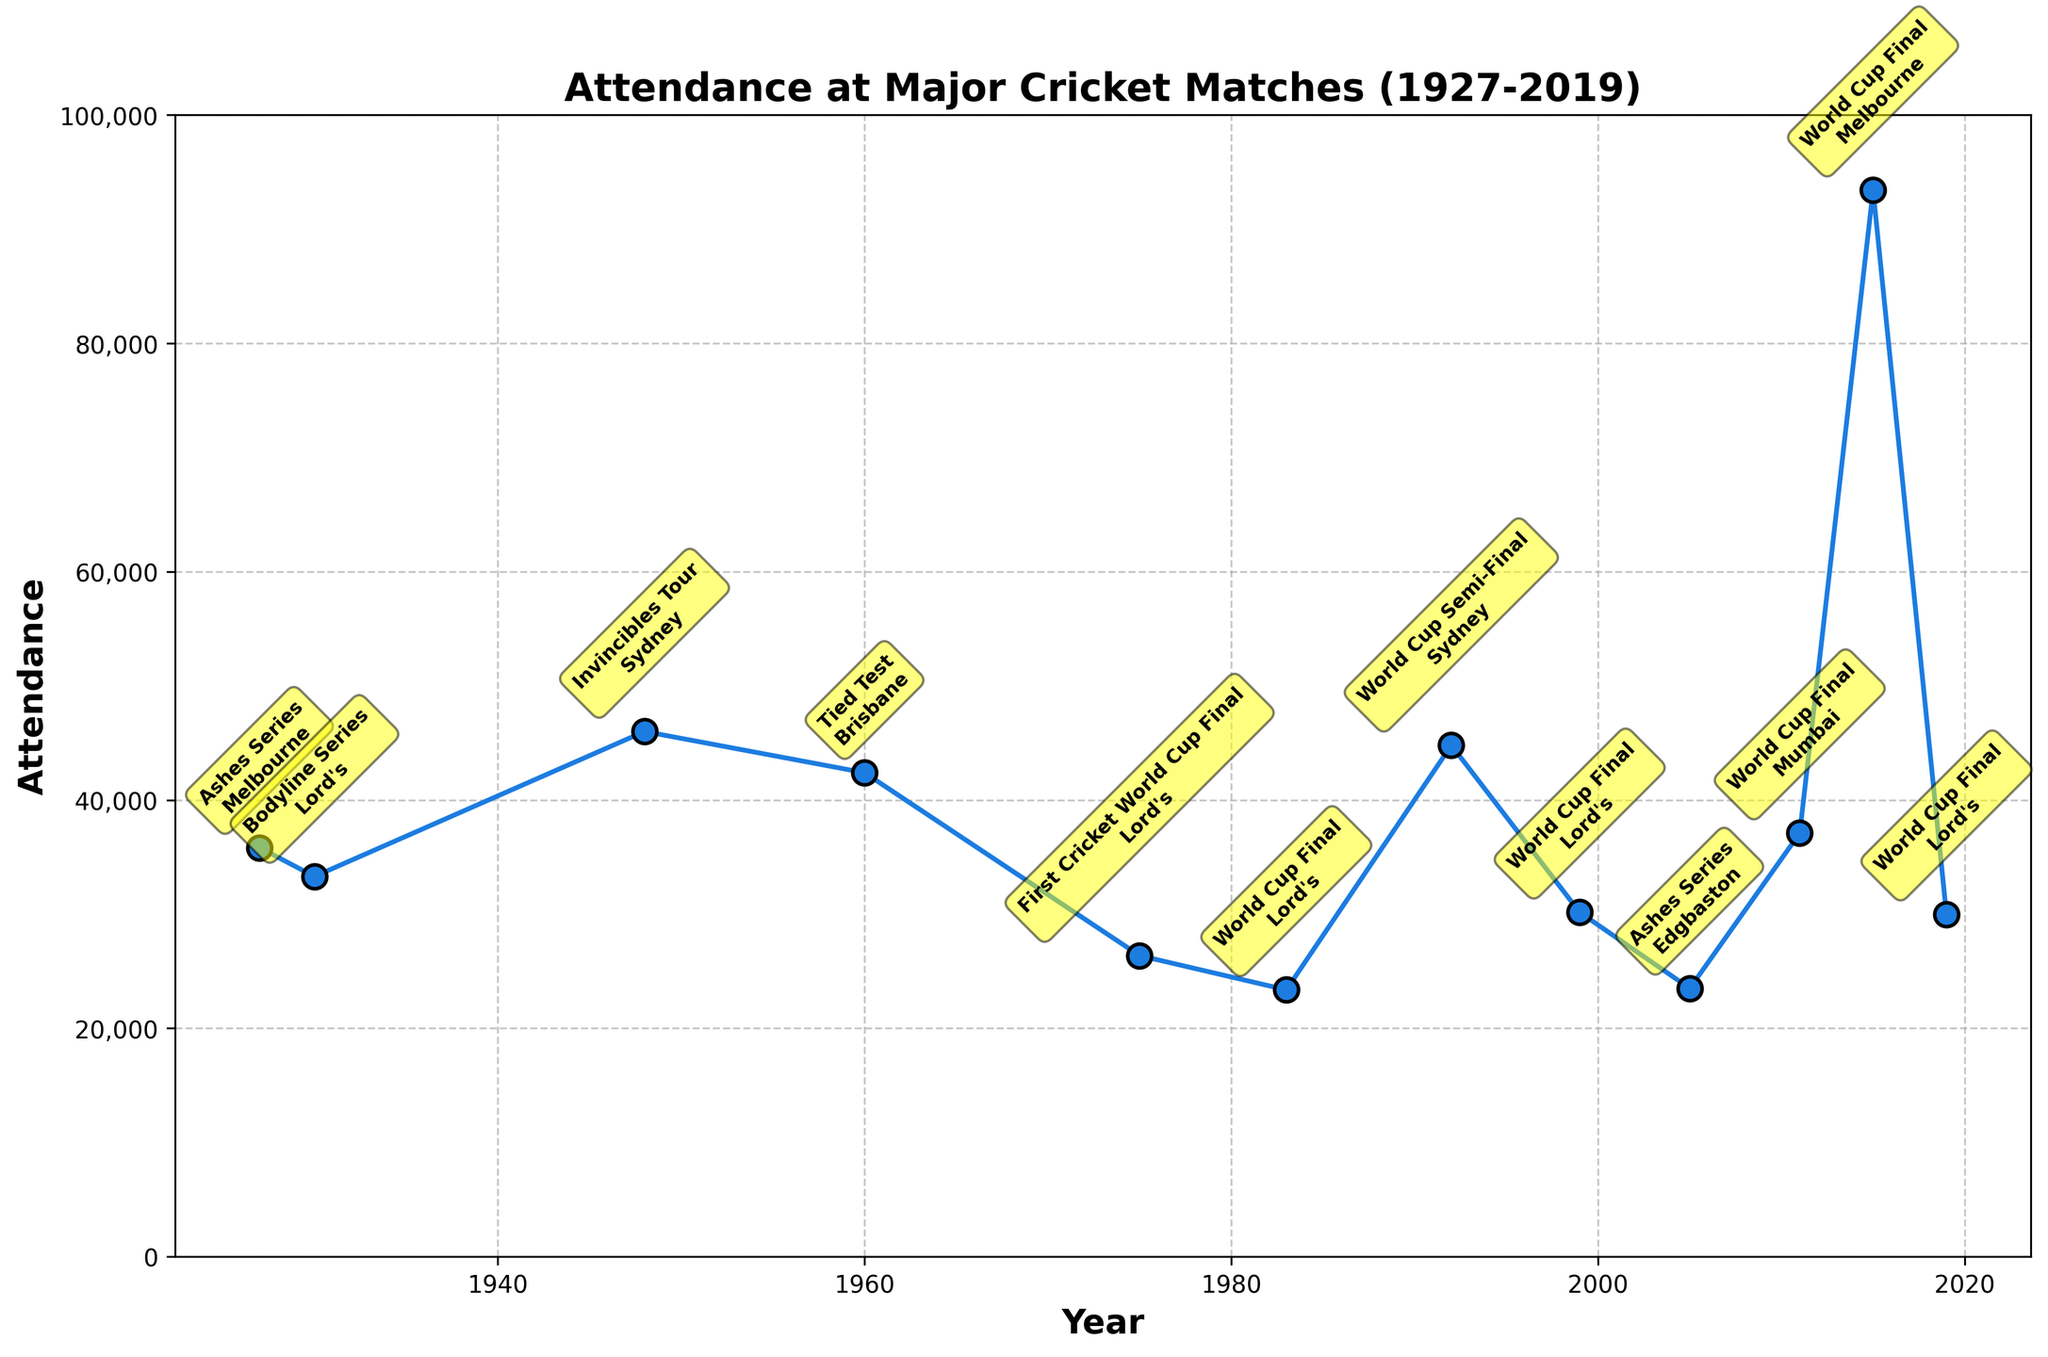What's the title of the figure? The title is placed at the top of the figure in bold text. It summarizes the main subject of the plot.
Answer: Attendance at Major Cricket Matches (1927-2019) How many major cricket matches are represented in the figure? There is one marker for each major cricket match on the plot, so count the markers to get the total number.
Answer: 12 Which event had the highest attendance? Look for the event with the highest marker position on the y-axis, which represents the highest value of attendance.
Answer: 2015 World Cup Final Which two events had the closest attendance figures? Compare the y-axis positions of markers that are near one another and check their exact attendance values to find the smallest difference.
Answer: 1975 First Cricket World Cup Final and 1983 World Cup Final What is the attendance difference between the 1948 Invincibles Tour and the 2005 Ashes Series? Locate their markers on the plot and subtract the 2005 Ashes Series attendance from the 1948 Invincibles Tour attendance.
Answer: 46000 - 23500 = 22500 How often was the World Cup Final held at Lord's based on the plot? Look for the "World Cup Final" events and count how many of them occurred at Lord's.
Answer: 3 Which event had the lowest attendance and what was its exact figure? Identify the marker at the lowest point on the y-axis, which indicates the lowest attendance, and check the text label for the exact number.
Answer: 2005 Ashes Series, 23500 In which year did the attendance drop significantly after increasing in the previous match? Identify any two consecutive markers where the latter is significantly lower than the former.
Answer: 2005 after 1999 How much did the attendance increase from the 1930 Bodyline Series to the 1948 Invincibles Tour? Subtract the attendance of the 1930 Bodyline Series from that of the 1948 Invincibles Tour.
Answer: 46000 - 33300 = 12700 What patterns or trends can be observed regarding the location of the events? Examine the annotations on each marker to see which locations are repeated or if there are any geographical trends in attendance.
Answer: Frequent events at Lord's, increases in attendance in later events 